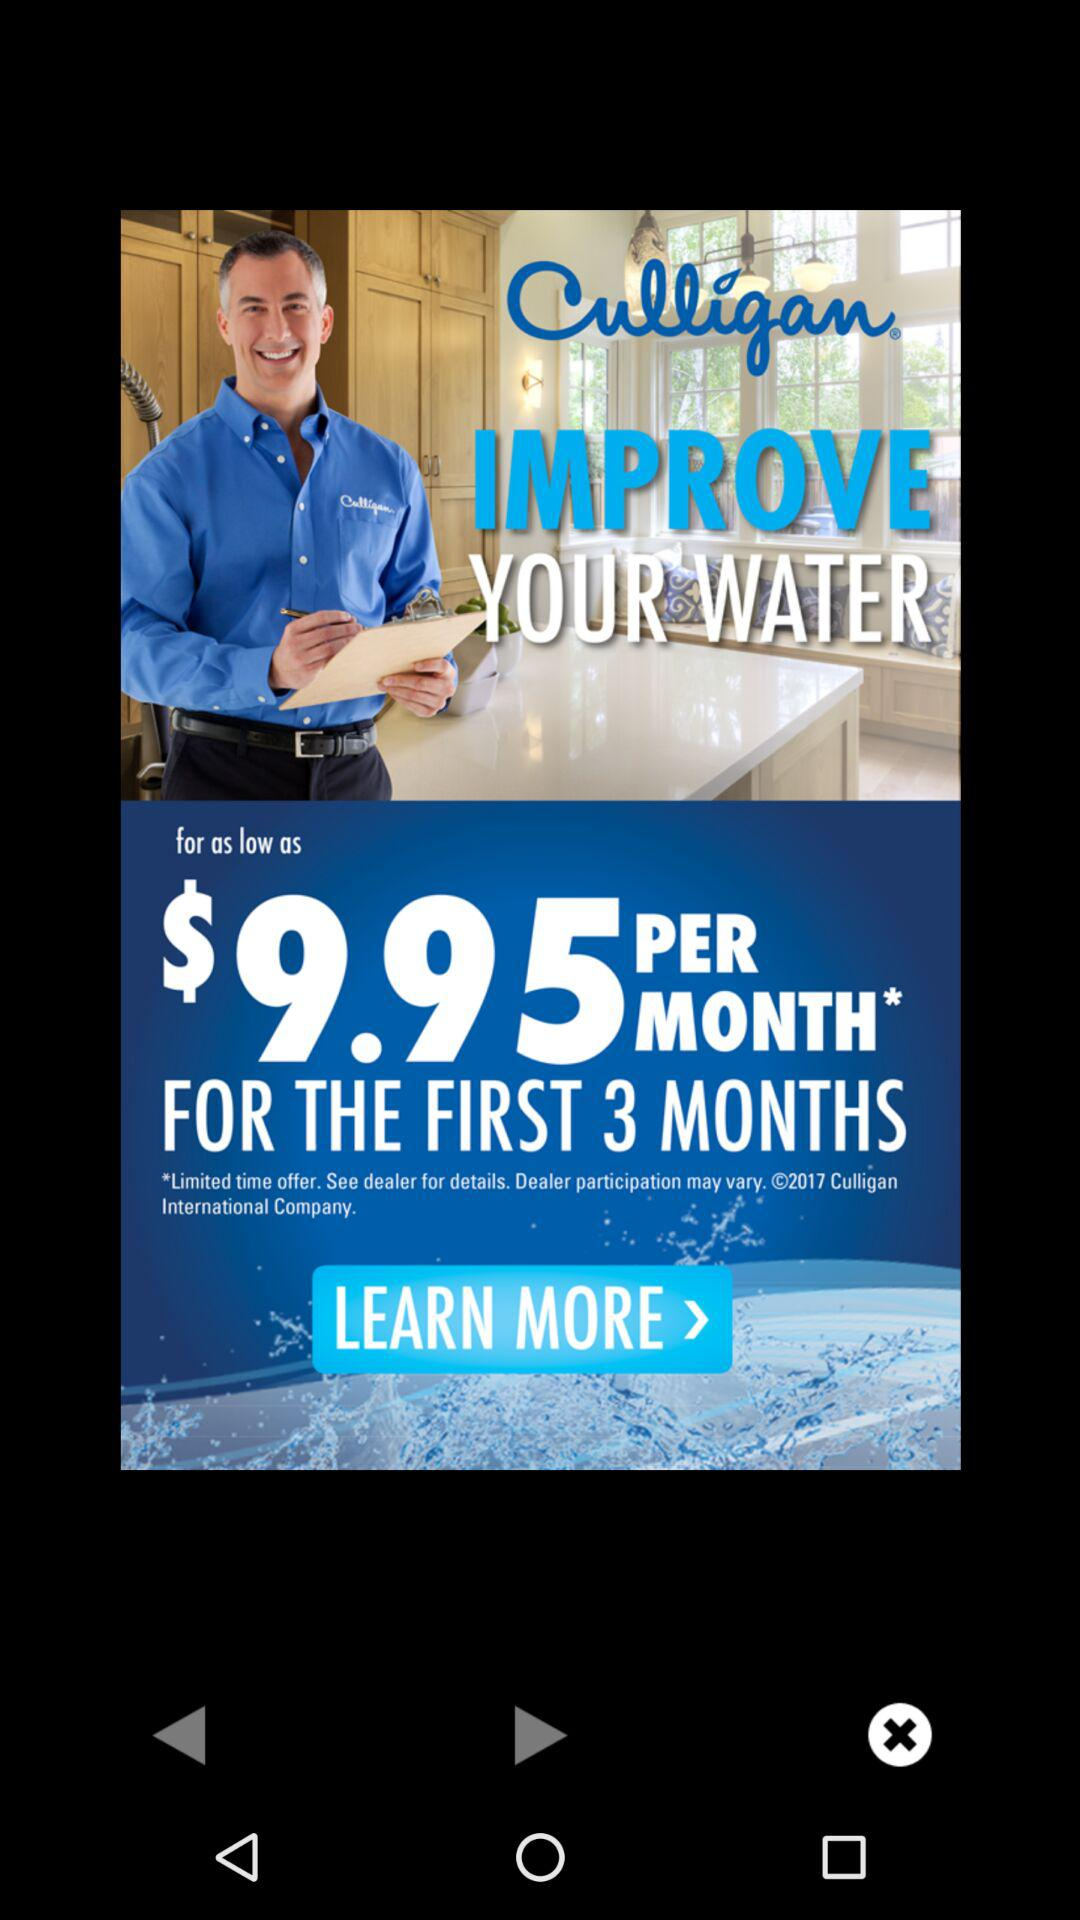How much is the monthly price for the first 3 months?
Answer the question using a single word or phrase. $9.95 